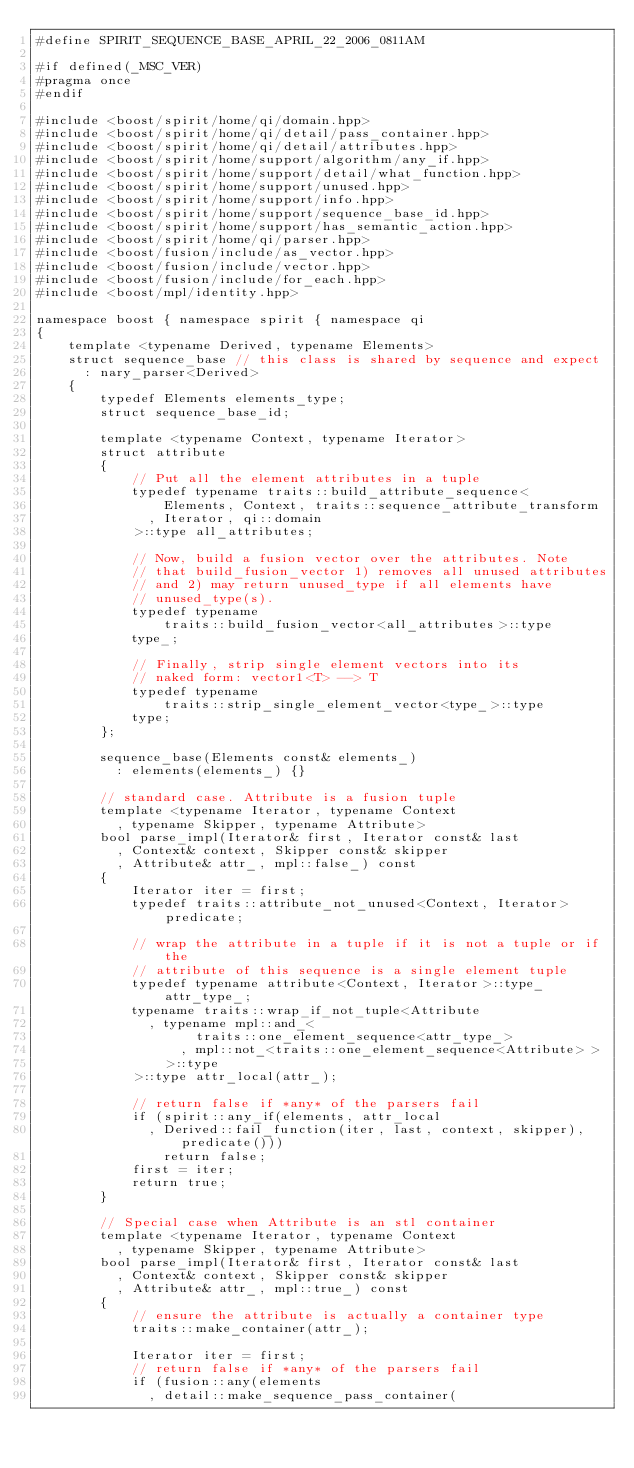Convert code to text. <code><loc_0><loc_0><loc_500><loc_500><_C++_>#define SPIRIT_SEQUENCE_BASE_APRIL_22_2006_0811AM

#if defined(_MSC_VER)
#pragma once
#endif

#include <boost/spirit/home/qi/domain.hpp>
#include <boost/spirit/home/qi/detail/pass_container.hpp>
#include <boost/spirit/home/qi/detail/attributes.hpp>
#include <boost/spirit/home/support/algorithm/any_if.hpp>
#include <boost/spirit/home/support/detail/what_function.hpp>
#include <boost/spirit/home/support/unused.hpp>
#include <boost/spirit/home/support/info.hpp>
#include <boost/spirit/home/support/sequence_base_id.hpp>
#include <boost/spirit/home/support/has_semantic_action.hpp>
#include <boost/spirit/home/qi/parser.hpp>
#include <boost/fusion/include/as_vector.hpp>
#include <boost/fusion/include/vector.hpp>
#include <boost/fusion/include/for_each.hpp>
#include <boost/mpl/identity.hpp>

namespace boost { namespace spirit { namespace qi
{
    template <typename Derived, typename Elements>
    struct sequence_base // this class is shared by sequence and expect
      : nary_parser<Derived>
    {
        typedef Elements elements_type;
        struct sequence_base_id;

        template <typename Context, typename Iterator>
        struct attribute
        {
            // Put all the element attributes in a tuple
            typedef typename traits::build_attribute_sequence<
                Elements, Context, traits::sequence_attribute_transform
              , Iterator, qi::domain
            >::type all_attributes;

            // Now, build a fusion vector over the attributes. Note
            // that build_fusion_vector 1) removes all unused attributes
            // and 2) may return unused_type if all elements have
            // unused_type(s).
            typedef typename
                traits::build_fusion_vector<all_attributes>::type
            type_;

            // Finally, strip single element vectors into its
            // naked form: vector1<T> --> T
            typedef typename
                traits::strip_single_element_vector<type_>::type
            type;
        };

        sequence_base(Elements const& elements_)
          : elements(elements_) {}

        // standard case. Attribute is a fusion tuple
        template <typename Iterator, typename Context
          , typename Skipper, typename Attribute>
        bool parse_impl(Iterator& first, Iterator const& last
          , Context& context, Skipper const& skipper
          , Attribute& attr_, mpl::false_) const
        {
            Iterator iter = first;
            typedef traits::attribute_not_unused<Context, Iterator> predicate;

            // wrap the attribute in a tuple if it is not a tuple or if the
            // attribute of this sequence is a single element tuple
            typedef typename attribute<Context, Iterator>::type_ attr_type_;
            typename traits::wrap_if_not_tuple<Attribute
              , typename mpl::and_<
                    traits::one_element_sequence<attr_type_>
                  , mpl::not_<traits::one_element_sequence<Attribute> >
                >::type
            >::type attr_local(attr_);

            // return false if *any* of the parsers fail
            if (spirit::any_if(elements, attr_local
              , Derived::fail_function(iter, last, context, skipper), predicate()))
                return false;
            first = iter;
            return true;
        }

        // Special case when Attribute is an stl container
        template <typename Iterator, typename Context
          , typename Skipper, typename Attribute>
        bool parse_impl(Iterator& first, Iterator const& last
          , Context& context, Skipper const& skipper
          , Attribute& attr_, mpl::true_) const
        {
            // ensure the attribute is actually a container type
            traits::make_container(attr_);

            Iterator iter = first;
            // return false if *any* of the parsers fail
            if (fusion::any(elements
              , detail::make_sequence_pass_container(</code> 